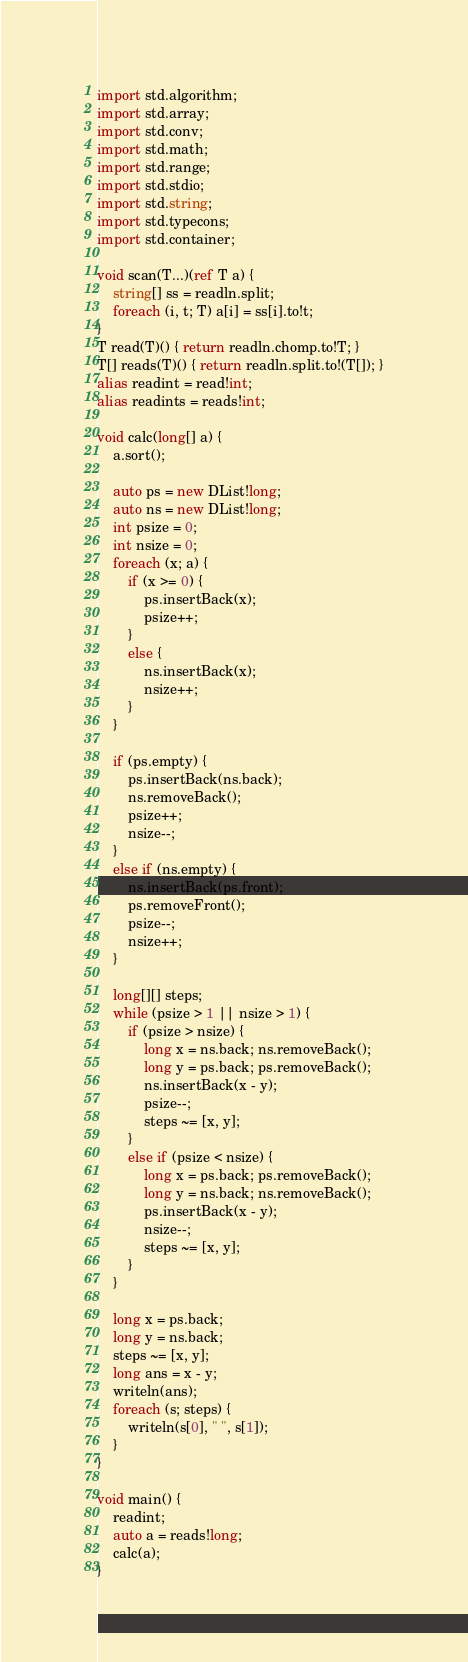<code> <loc_0><loc_0><loc_500><loc_500><_D_>import std.algorithm;
import std.array;
import std.conv;
import std.math;
import std.range;
import std.stdio;
import std.string;
import std.typecons;
import std.container;

void scan(T...)(ref T a) {
    string[] ss = readln.split;
    foreach (i, t; T) a[i] = ss[i].to!t;
}
T read(T)() { return readln.chomp.to!T; }
T[] reads(T)() { return readln.split.to!(T[]); }
alias readint = read!int;
alias readints = reads!int;

void calc(long[] a) {
    a.sort();

    auto ps = new DList!long;
    auto ns = new DList!long;
    int psize = 0;
    int nsize = 0;
    foreach (x; a) {
        if (x >= 0) {
            ps.insertBack(x);
            psize++;
        }
        else {
            ns.insertBack(x);
            nsize++;
        }
    }

    if (ps.empty) {
        ps.insertBack(ns.back);
        ns.removeBack();
        psize++;
        nsize--;
    }
    else if (ns.empty) {
        ns.insertBack(ps.front);
        ps.removeFront();
        psize--;
        nsize++;
    }

    long[][] steps;
    while (psize > 1 || nsize > 1) {
        if (psize > nsize) {
            long x = ns.back; ns.removeBack();
            long y = ps.back; ps.removeBack();
            ns.insertBack(x - y);
            psize--;
            steps ~= [x, y];
        }
        else if (psize < nsize) {
            long x = ps.back; ps.removeBack();
            long y = ns.back; ns.removeBack();
            ps.insertBack(x - y);
            nsize--;
            steps ~= [x, y];
        }
    }

    long x = ps.back;
    long y = ns.back;
    steps ~= [x, y];
    long ans = x - y;
    writeln(ans);
    foreach (s; steps) {
        writeln(s[0], " ", s[1]);
    }
}

void main() {
    readint;
    auto a = reads!long;
    calc(a);
}
</code> 